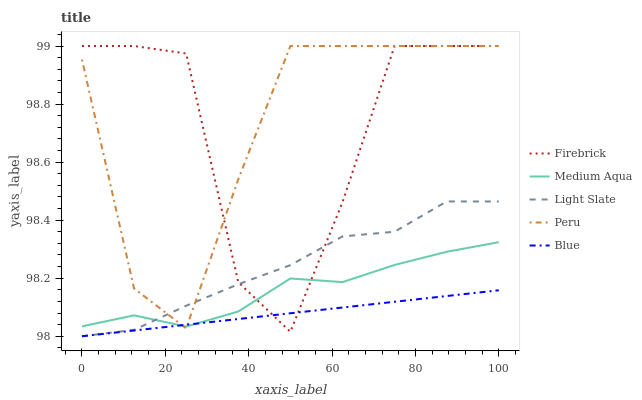Does Firebrick have the minimum area under the curve?
Answer yes or no. No. Does Firebrick have the maximum area under the curve?
Answer yes or no. No. Is Firebrick the smoothest?
Answer yes or no. No. Is Blue the roughest?
Answer yes or no. No. Does Firebrick have the lowest value?
Answer yes or no. No. Does Blue have the highest value?
Answer yes or no. No. 